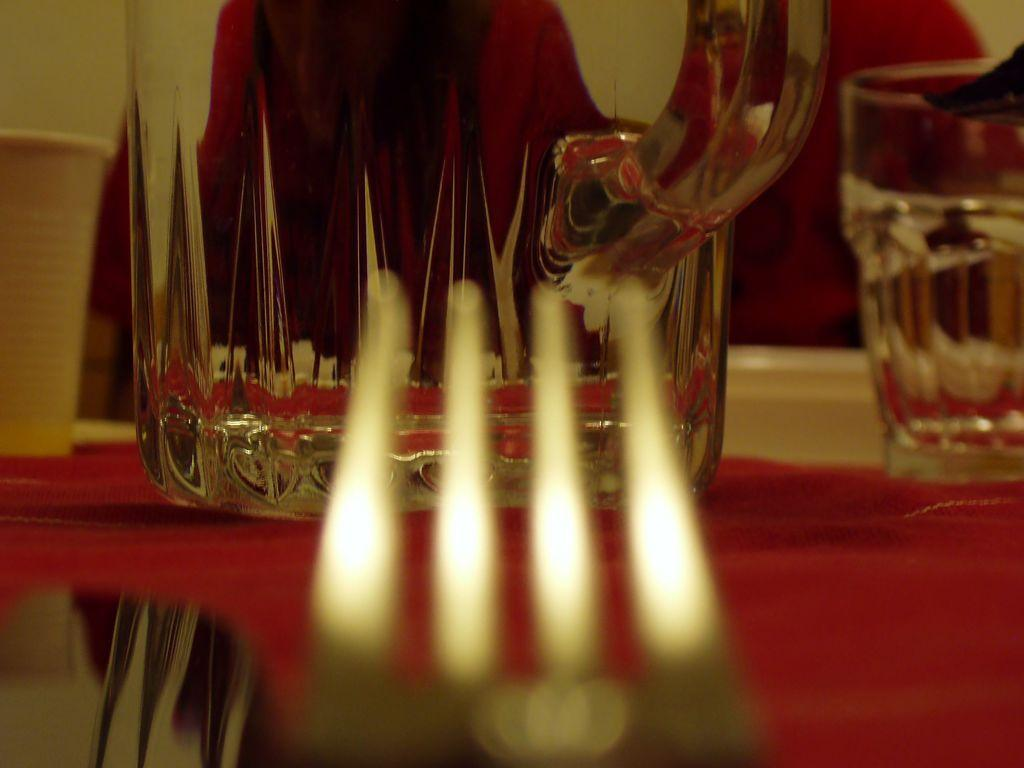What object is located in the foreground of the image? There is a fork in the foreground of the image. What objects are on the table in the middle of the image? There are glasses and a glass mug on the table in the middle of the image. Can you describe the people in the background of the image? There are persons in the background of the image, but their specific actions or characteristics are not mentioned in the provided facts. What is visible in the background of the image? There is a wall in the background of the image. What type of knowledge is being shared at the event in the image? There is no event or knowledge sharing present in the image; it features a fork, glasses, a glass mug, and persons in the background. What shape is the circle that the persons are forming in the image? There is no circle or specific formation of persons in the image; they are simply present in the background. 